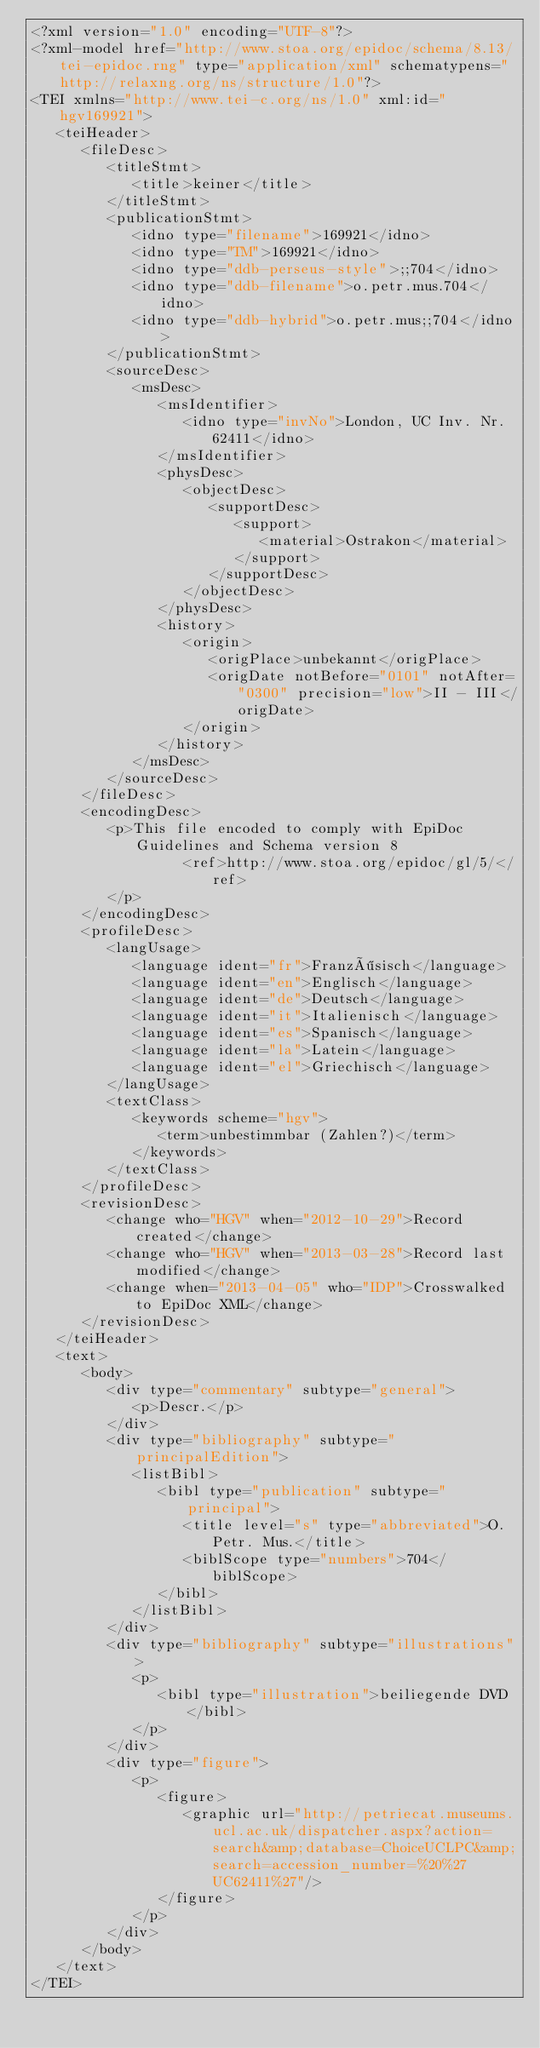<code> <loc_0><loc_0><loc_500><loc_500><_XML_><?xml version="1.0" encoding="UTF-8"?>
<?xml-model href="http://www.stoa.org/epidoc/schema/8.13/tei-epidoc.rng" type="application/xml" schematypens="http://relaxng.org/ns/structure/1.0"?>
<TEI xmlns="http://www.tei-c.org/ns/1.0" xml:id="hgv169921">
   <teiHeader>
      <fileDesc>
         <titleStmt>
            <title>keiner</title>
         </titleStmt>
         <publicationStmt>
            <idno type="filename">169921</idno>
            <idno type="TM">169921</idno>
            <idno type="ddb-perseus-style">;;704</idno>
            <idno type="ddb-filename">o.petr.mus.704</idno>
            <idno type="ddb-hybrid">o.petr.mus;;704</idno>
         </publicationStmt>
         <sourceDesc>
            <msDesc>
               <msIdentifier>
                  <idno type="invNo">London, UC Inv. Nr. 62411</idno>
               </msIdentifier>
               <physDesc>
                  <objectDesc>
                     <supportDesc>
                        <support>
                           <material>Ostrakon</material>
                        </support>
                     </supportDesc>
                  </objectDesc>
               </physDesc>
               <history>
                  <origin>
                     <origPlace>unbekannt</origPlace>
                     <origDate notBefore="0101" notAfter="0300" precision="low">II - III</origDate>
                  </origin>
               </history>
            </msDesc>
         </sourceDesc>
      </fileDesc>
      <encodingDesc>
         <p>This file encoded to comply with EpiDoc Guidelines and Schema version 8
                  <ref>http://www.stoa.org/epidoc/gl/5/</ref>
         </p>
      </encodingDesc>
      <profileDesc>
         <langUsage>
            <language ident="fr">Französisch</language>
            <language ident="en">Englisch</language>
            <language ident="de">Deutsch</language>
            <language ident="it">Italienisch</language>
            <language ident="es">Spanisch</language>
            <language ident="la">Latein</language>
            <language ident="el">Griechisch</language>
         </langUsage>
         <textClass>
            <keywords scheme="hgv">
               <term>unbestimmbar (Zahlen?)</term>
            </keywords>
         </textClass>
      </profileDesc>
      <revisionDesc>
         <change who="HGV" when="2012-10-29">Record created</change>
         <change who="HGV" when="2013-03-28">Record last modified</change>
         <change when="2013-04-05" who="IDP">Crosswalked to EpiDoc XML</change>
      </revisionDesc>
   </teiHeader>
   <text>
      <body>
         <div type="commentary" subtype="general">
            <p>Descr.</p>
         </div>
         <div type="bibliography" subtype="principalEdition">
            <listBibl>
               <bibl type="publication" subtype="principal">
                  <title level="s" type="abbreviated">O.Petr. Mus.</title>
                  <biblScope type="numbers">704</biblScope>
               </bibl>
            </listBibl>
         </div>
         <div type="bibliography" subtype="illustrations">
            <p>
               <bibl type="illustration">beiliegende DVD</bibl>
            </p>
         </div>
         <div type="figure">
            <p>
               <figure>
                  <graphic url="http://petriecat.museums.ucl.ac.uk/dispatcher.aspx?action=search&amp;database=ChoiceUCLPC&amp;search=accession_number=%20%27UC62411%27"/>
               </figure>
            </p>
         </div>
      </body>
   </text>
</TEI>
</code> 